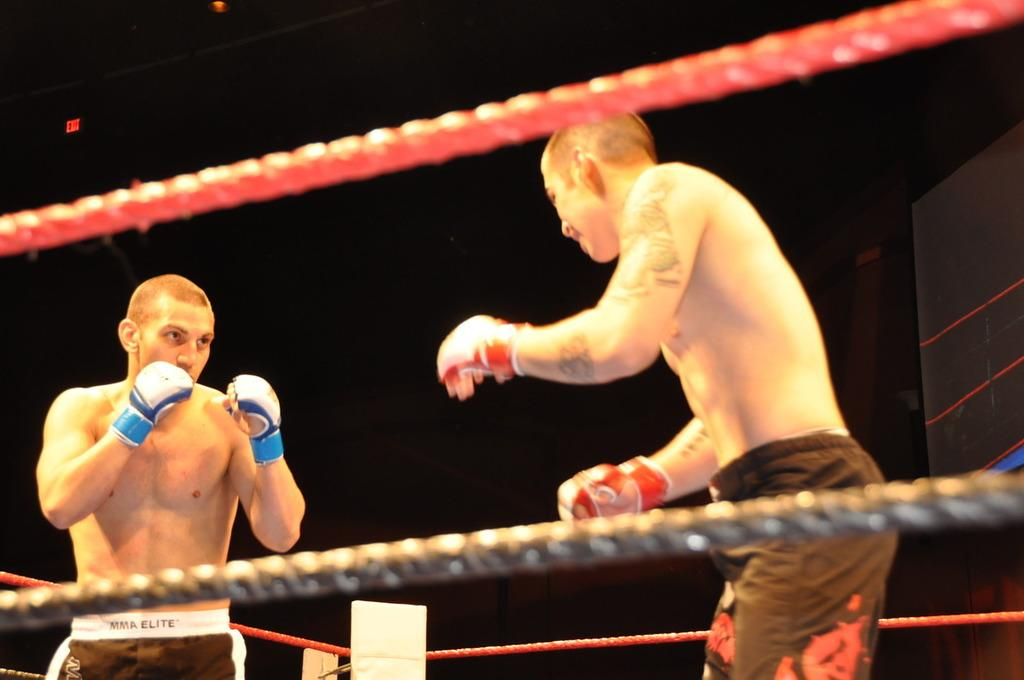How many people are in the image? There are two men in the image. What are the men wearing on their hands? The men are wearing gloves. What objects can be seen in the image besides the men? There are ropes in the image. What can be observed about the background of the image? The background of the image is dark. What type of cherry is being used to climb the ropes in the image? There is no cherry present in the image, and the men are not using any fruit to climb the ropes. What kind of building can be seen in the background of the image? There is no building visible in the background of the image; it is dark. 